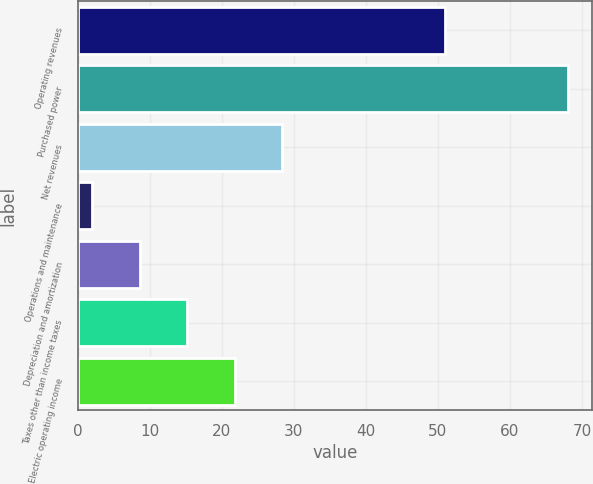Convert chart to OTSL. <chart><loc_0><loc_0><loc_500><loc_500><bar_chart><fcel>Operating revenues<fcel>Purchased power<fcel>Net revenues<fcel>Operations and maintenance<fcel>Depreciation and amortization<fcel>Taxes other than income taxes<fcel>Electric operating income<nl><fcel>51<fcel>68<fcel>28.4<fcel>2<fcel>8.6<fcel>15.2<fcel>21.8<nl></chart> 